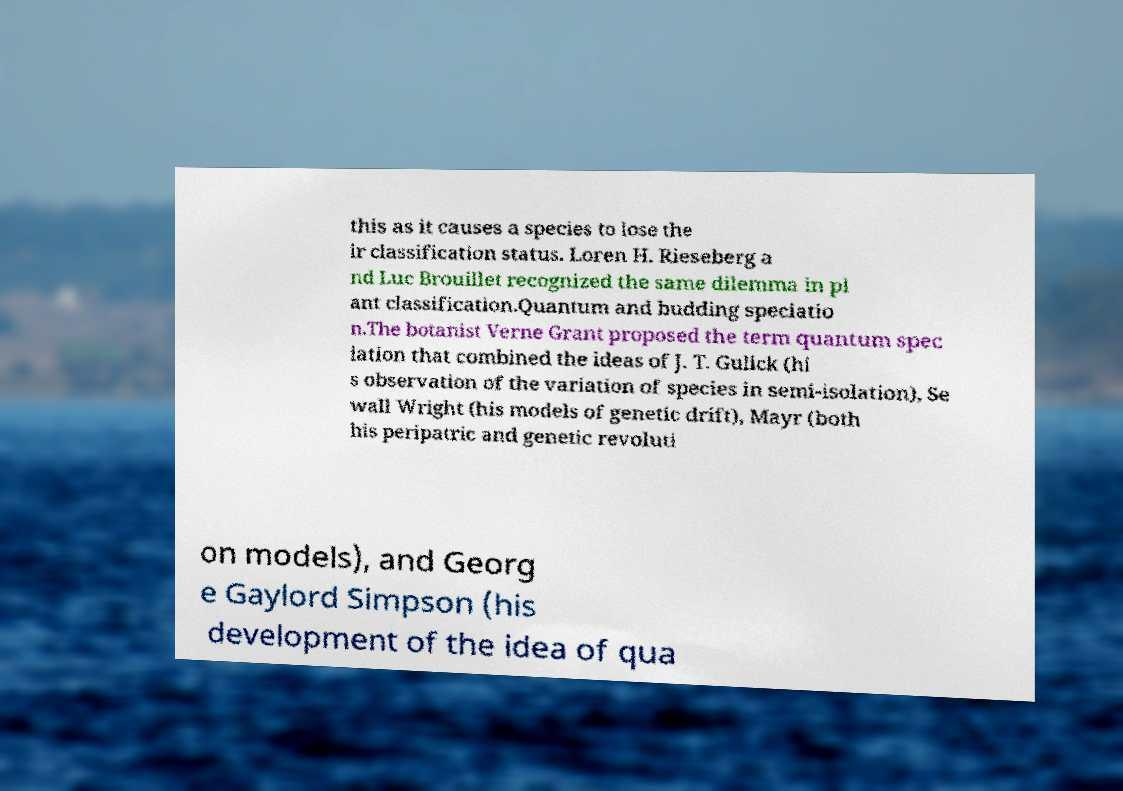Please identify and transcribe the text found in this image. this as it causes a species to lose the ir classification status. Loren H. Rieseberg a nd Luc Brouillet recognized the same dilemma in pl ant classification.Quantum and budding speciatio n.The botanist Verne Grant proposed the term quantum spec iation that combined the ideas of J. T. Gulick (hi s observation of the variation of species in semi-isolation), Se wall Wright (his models of genetic drift), Mayr (both his peripatric and genetic revoluti on models), and Georg e Gaylord Simpson (his development of the idea of qua 